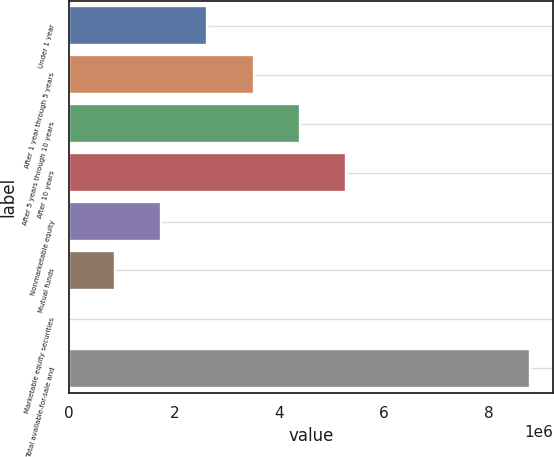Convert chart to OTSL. <chart><loc_0><loc_0><loc_500><loc_500><bar_chart><fcel>Under 1 year<fcel>After 1 year through 5 years<fcel>After 5 years through 10 years<fcel>After 10 years<fcel>Nonmarketable equity<fcel>Mutual funds<fcel>Marketable equity securities<fcel>Total available-for-sale and<nl><fcel>2.63319e+06<fcel>3.51065e+06<fcel>4.38812e+06<fcel>5.26558e+06<fcel>1.75572e+06<fcel>878259<fcel>794<fcel>8.77544e+06<nl></chart> 